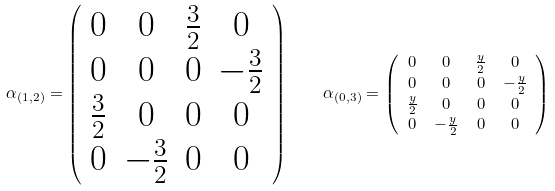Convert formula to latex. <formula><loc_0><loc_0><loc_500><loc_500>\alpha _ { ( 1 , 2 ) } = \left ( \begin{array} { c c c c } 0 & 0 & \frac { 3 } { 2 } & 0 \\ 0 & 0 & 0 & - \frac { 3 } { 2 } \\ \frac { 3 } { 2 } & 0 & 0 & 0 \\ 0 & - \frac { 3 } { 2 } & 0 & 0 \end{array} \right ) \quad & \alpha _ { ( 0 , 3 ) } = \left ( \begin{array} { c c c c } 0 & 0 & \frac { y } { 2 } & 0 \\ 0 & 0 & 0 & - \frac { y } { 2 } \\ \frac { y } { 2 } & 0 & 0 & 0 \\ 0 & - \frac { y } { 2 } & 0 & 0 \end{array} \right )</formula> 